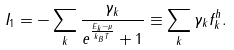Convert formula to latex. <formula><loc_0><loc_0><loc_500><loc_500>I _ { 1 } = - \sum _ { k } \frac { \gamma _ { k } } { e ^ { \frac { E _ { k } - \mu } { k _ { B } T } } + 1 } \equiv \sum _ { k } \gamma _ { k } f _ { k } ^ { h } .</formula> 